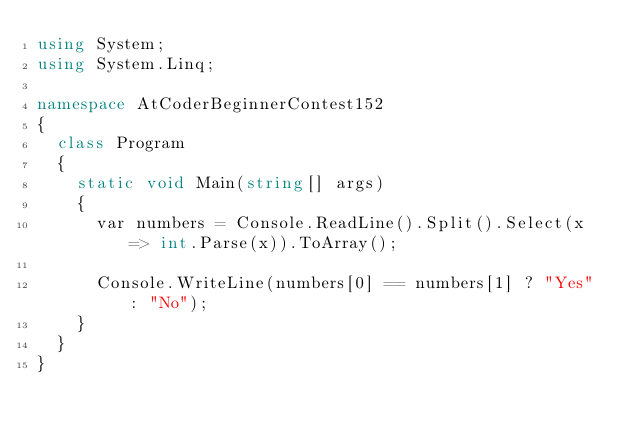<code> <loc_0><loc_0><loc_500><loc_500><_C#_>using System;
using System.Linq;

namespace AtCoderBeginnerContest152
{
	class Program
	{
		static void Main(string[] args)
		{
			var numbers = Console.ReadLine().Split().Select(x => int.Parse(x)).ToArray();

			Console.WriteLine(numbers[0] == numbers[1] ? "Yes" : "No");
		}
	}
}
</code> 